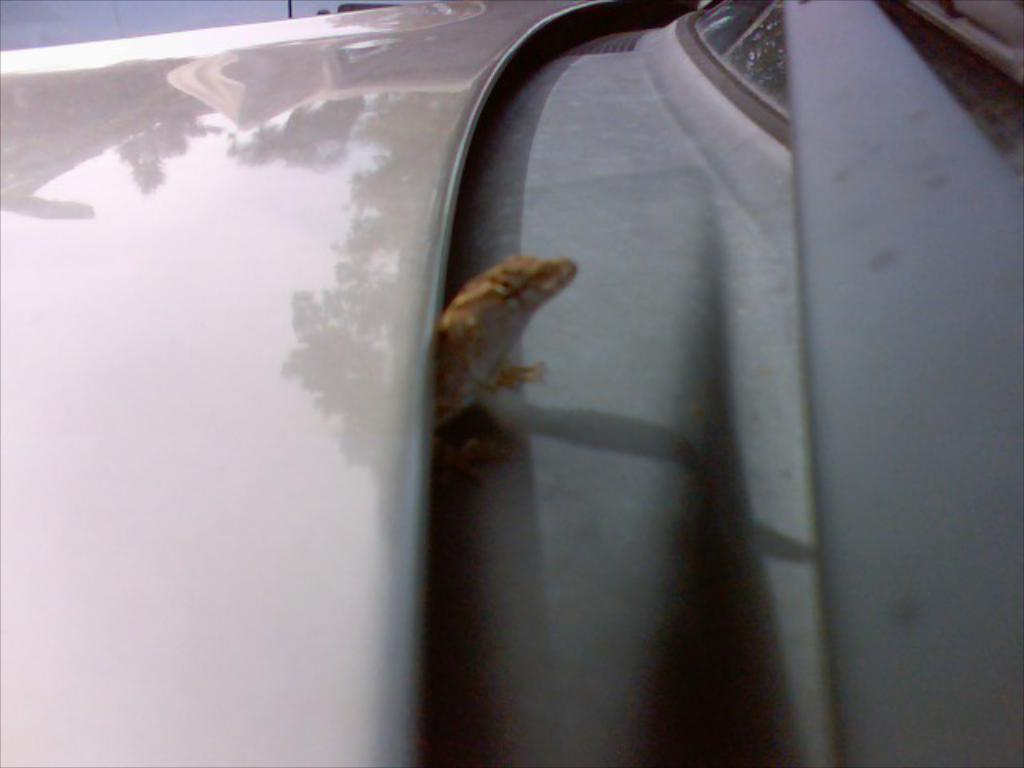What is the main subject in the center of the image? There is a car in the center of the image. Are there any other objects or creatures on the car? Yes, there is a frog on the car. How does the car expand in the image? The car does not expand in the image; it is a stationary object with a fixed size. 